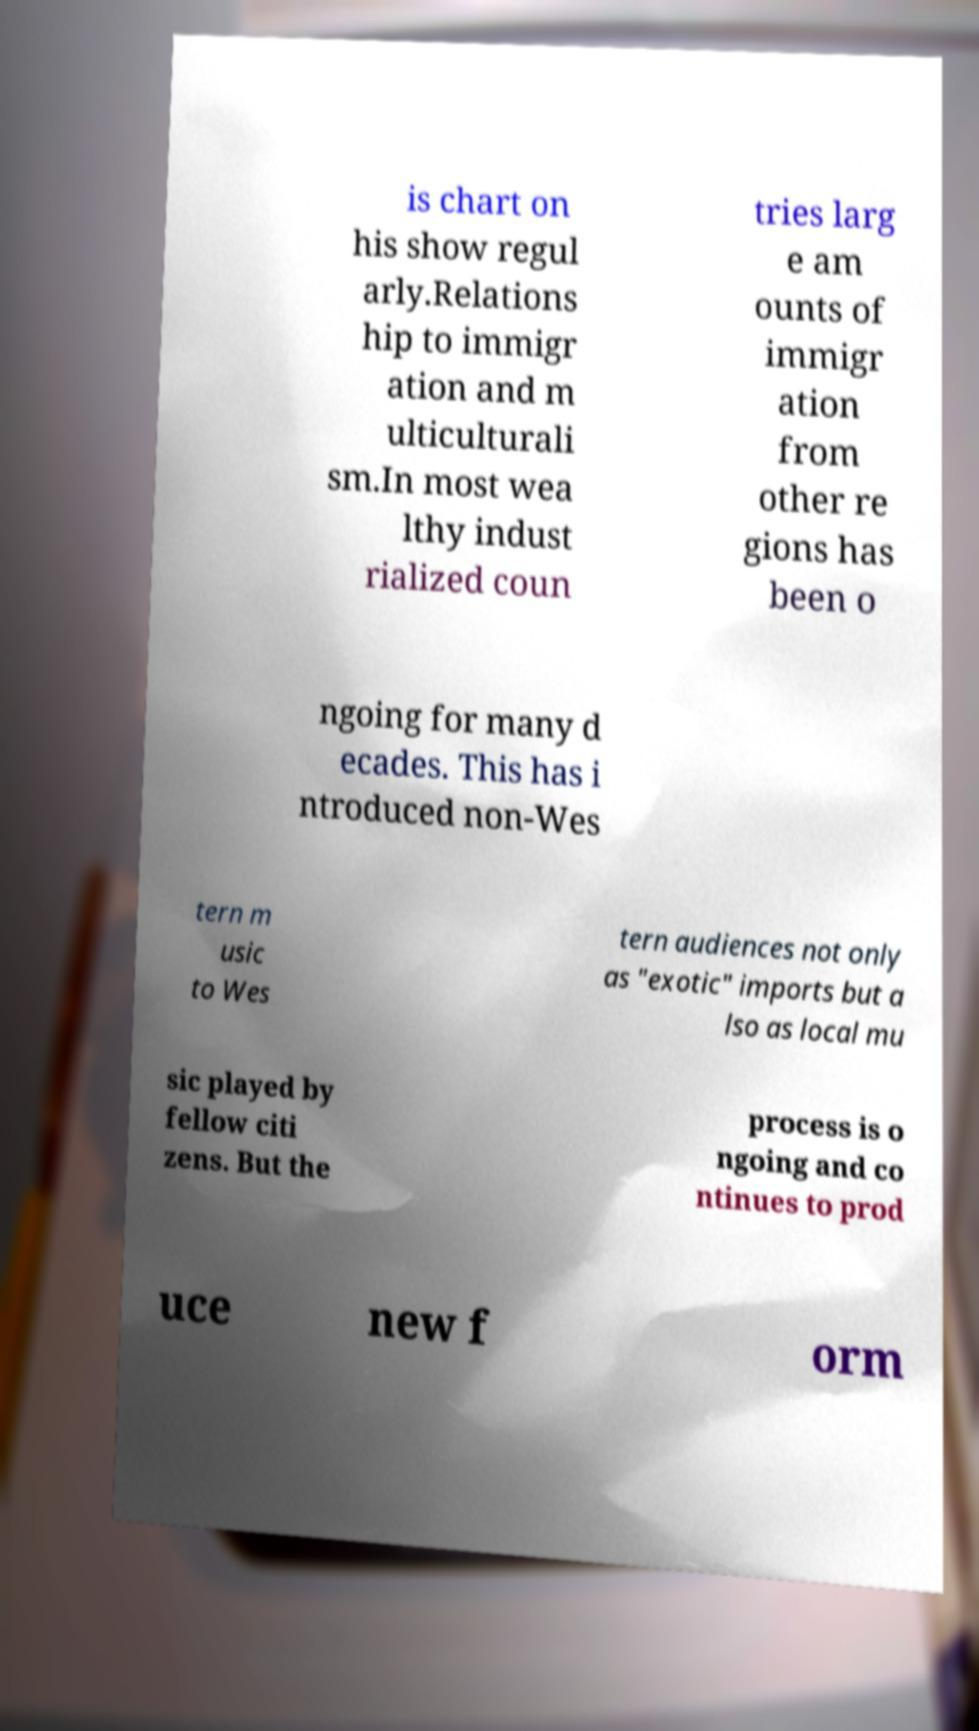Can you accurately transcribe the text from the provided image for me? is chart on his show regul arly.Relations hip to immigr ation and m ulticulturali sm.In most wea lthy indust rialized coun tries larg e am ounts of immigr ation from other re gions has been o ngoing for many d ecades. This has i ntroduced non-Wes tern m usic to Wes tern audiences not only as "exotic" imports but a lso as local mu sic played by fellow citi zens. But the process is o ngoing and co ntinues to prod uce new f orm 